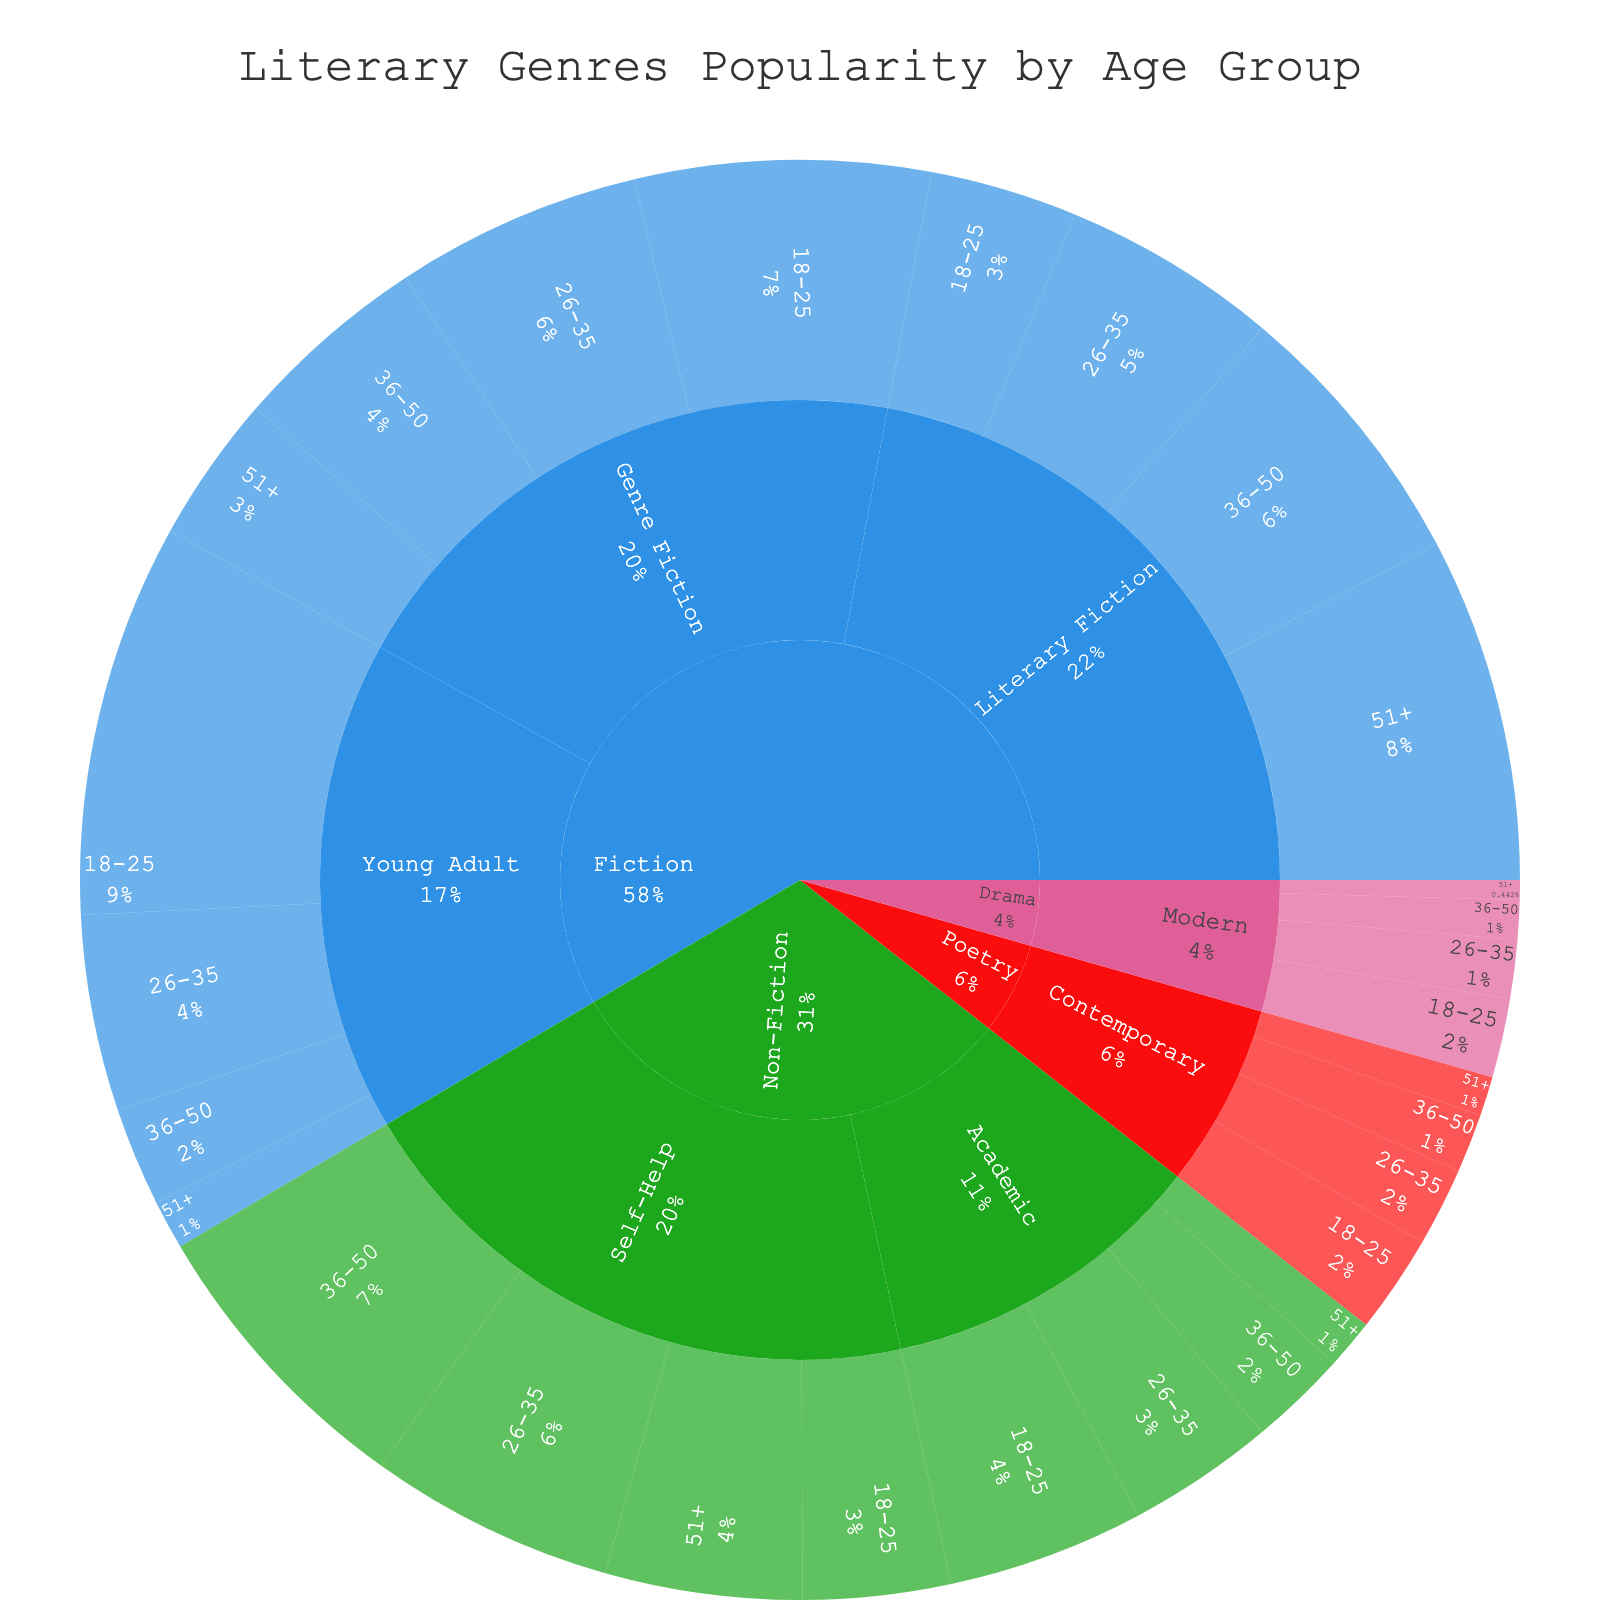What's the most popular literary genre among the 18-25 age group? By looking at the outer ring representing the age group 18-25, we can see that Young Adult Fiction has the highest share.
Answer: Young Adult Fiction What percentage of the total popularity does Literary Fiction hold? Literary Fiction has four sections across age groups. We need to sum their percentages, which are visible in the diagram. The percentages are 15%, 22%, 28%, and 35%. Adding them gives 15 + 22 + 28 + 35 = 100%.
Answer: 100% Which literary subgenre is the least popular among people aged 51+? Looking at the outer ring labeled 51+, we observe that Modern Drama has the smallest segment.
Answer: Modern Drama How does the popularity of Academic Non-Fiction change with age? For the Academic Non-Fiction subgenre, the popularity values by age group are 20 (18-25), 15 (26-35), 10 (36-50), and 5 (51+). This shows a decreasing trend as age increases.
Answer: Decreases with age Compare the popularity of Self-Help Non-Fiction among the 36-50 and 51+ age groups. The segment for 36-50 is 30%, and for 51+, it's 20%. Therefore, Self-Help is more popular among the 36-50 group by 10 percentage points.
Answer: 36-50 is more popular by 10 points What is the combined popularity percentage of Fiction genres among the 18-25 age group? Adding the percentages for Literary Fiction (15%), Genre Fiction (30%), and Young Adult (40%) gives 15 + 30 + 40 = 85%.
Answer: 85% Which age group has the highest preference for Genre Fiction? By examining the segments for Genre Fiction across age groups, the group 18-25 has the highest percentage (30%).
Answer: 18-25 How far apart are the popularity figures of Contemporary Poetry for the youngest and oldest age groups? For Contemporary Poetry, the 18-25 group is 10%, and the 51+ group is 4%. The difference is 10 - 4 = 6%.
Answer: 6% What is the total popularity of fiction genres for people aged 51+? Summing up the percentages from Literary Fiction (35%), Genre Fiction (15%), and Young Adult (5%) gives 35 + 15 + 5 = 55%.
Answer: 55% Which subgenre under Fiction is the least popular among people aged 26-35? Within Fiction and the 26-35 age ring, the smallest segment is for Young Adult Fiction at 20%.
Answer: Young Adult Fiction 